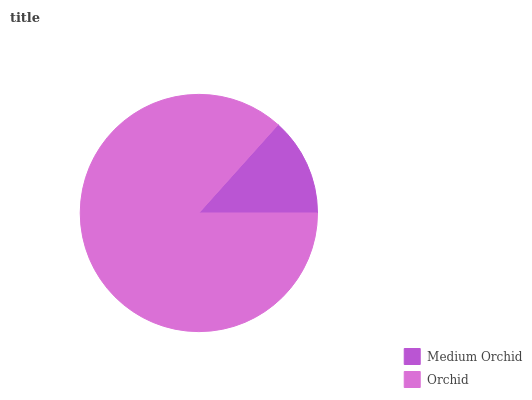Is Medium Orchid the minimum?
Answer yes or no. Yes. Is Orchid the maximum?
Answer yes or no. Yes. Is Orchid the minimum?
Answer yes or no. No. Is Orchid greater than Medium Orchid?
Answer yes or no. Yes. Is Medium Orchid less than Orchid?
Answer yes or no. Yes. Is Medium Orchid greater than Orchid?
Answer yes or no. No. Is Orchid less than Medium Orchid?
Answer yes or no. No. Is Orchid the high median?
Answer yes or no. Yes. Is Medium Orchid the low median?
Answer yes or no. Yes. Is Medium Orchid the high median?
Answer yes or no. No. Is Orchid the low median?
Answer yes or no. No. 